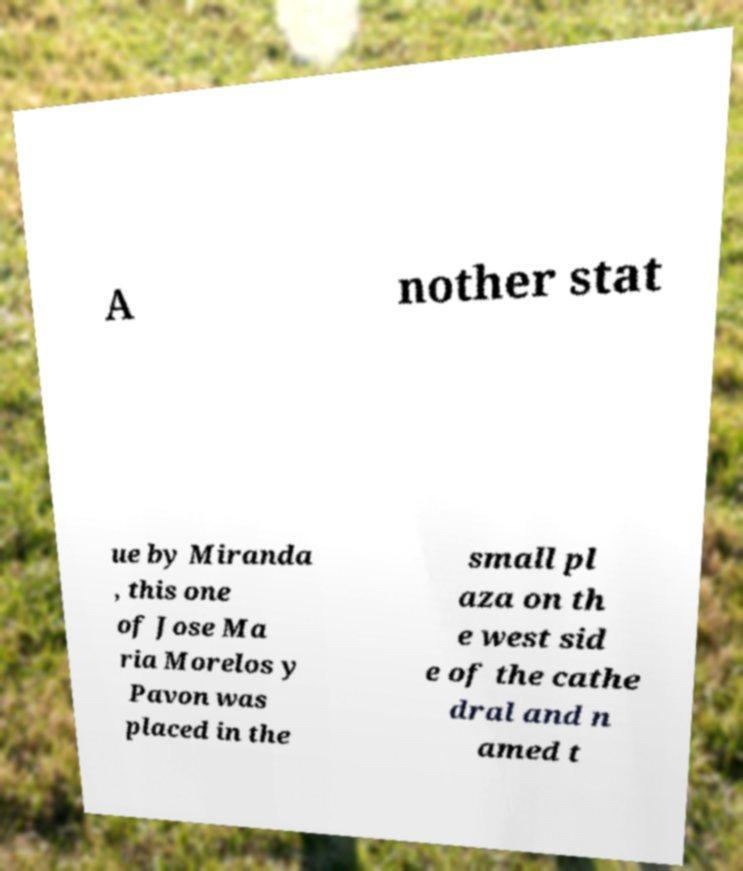Could you assist in decoding the text presented in this image and type it out clearly? A nother stat ue by Miranda , this one of Jose Ma ria Morelos y Pavon was placed in the small pl aza on th e west sid e of the cathe dral and n amed t 